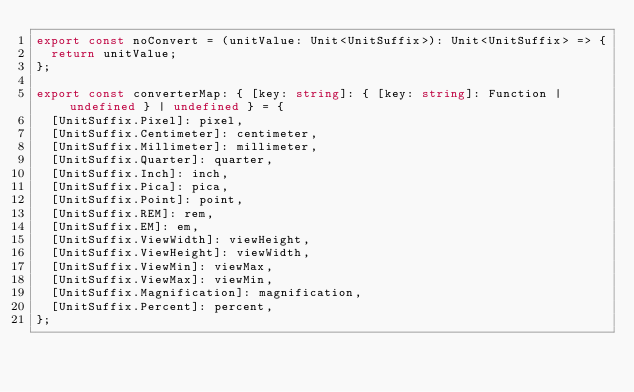<code> <loc_0><loc_0><loc_500><loc_500><_TypeScript_>export const noConvert = (unitValue: Unit<UnitSuffix>): Unit<UnitSuffix> => {
  return unitValue;
};

export const converterMap: { [key: string]: { [key: string]: Function | undefined } | undefined } = {
  [UnitSuffix.Pixel]: pixel,
  [UnitSuffix.Centimeter]: centimeter,
  [UnitSuffix.Millimeter]: millimeter,
  [UnitSuffix.Quarter]: quarter,
  [UnitSuffix.Inch]: inch,
  [UnitSuffix.Pica]: pica,
  [UnitSuffix.Point]: point,
  [UnitSuffix.REM]: rem,
  [UnitSuffix.EM]: em,
  [UnitSuffix.ViewWidth]: viewHeight,
  [UnitSuffix.ViewHeight]: viewWidth,
  [UnitSuffix.ViewMin]: viewMax,
  [UnitSuffix.ViewMax]: viewMin,
  [UnitSuffix.Magnification]: magnification,
  [UnitSuffix.Percent]: percent,
};
</code> 